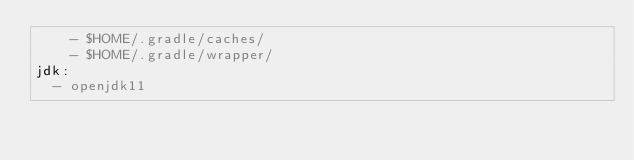Convert code to text. <code><loc_0><loc_0><loc_500><loc_500><_YAML_>    - $HOME/.gradle/caches/
    - $HOME/.gradle/wrapper/
jdk:
  - openjdk11
</code> 